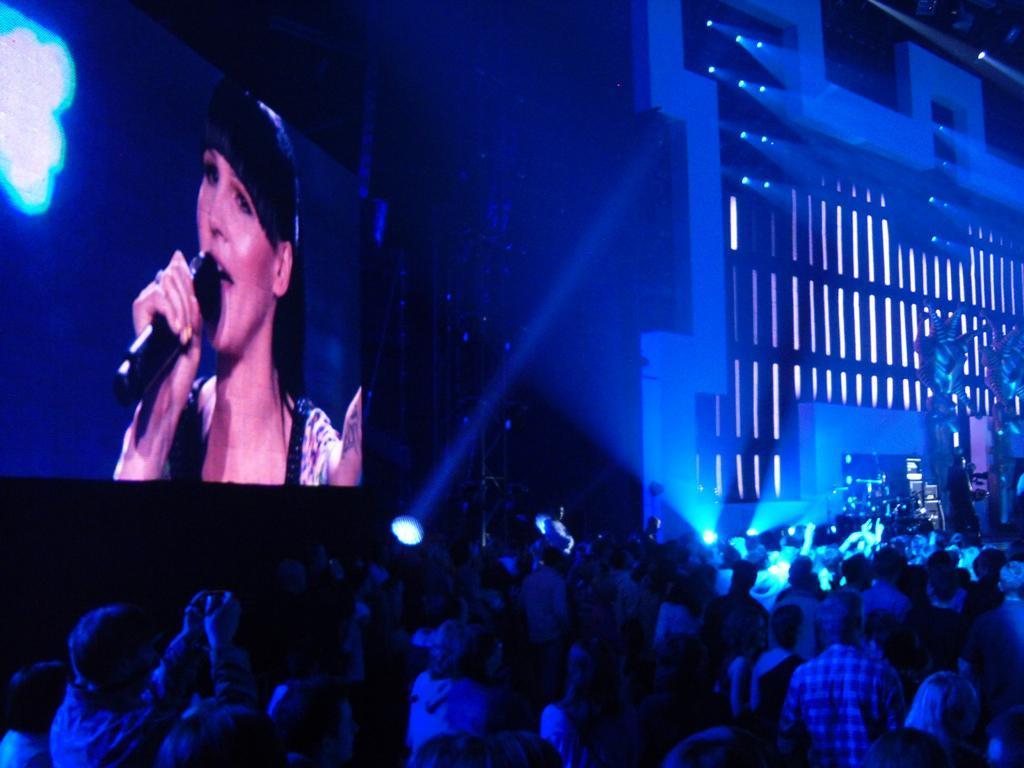Please provide a concise description of this image. This picture describes about group of people, in the background we can see few lights, screen and a building. 